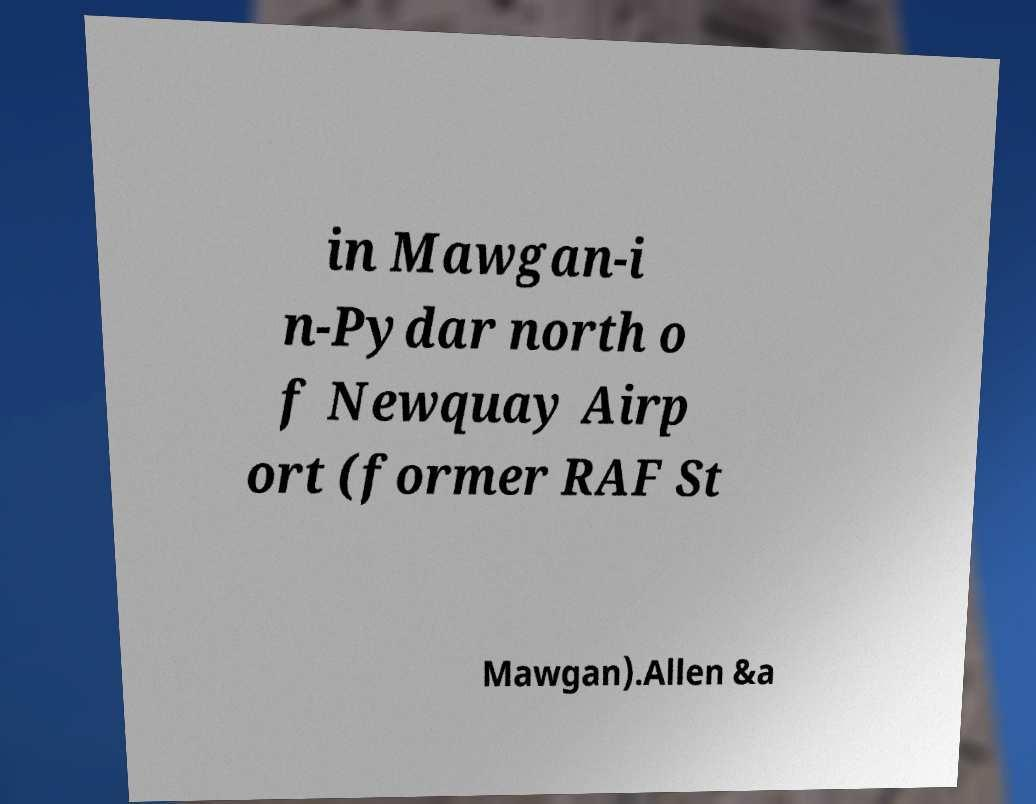For documentation purposes, I need the text within this image transcribed. Could you provide that? in Mawgan-i n-Pydar north o f Newquay Airp ort (former RAF St Mawgan).Allen &a 